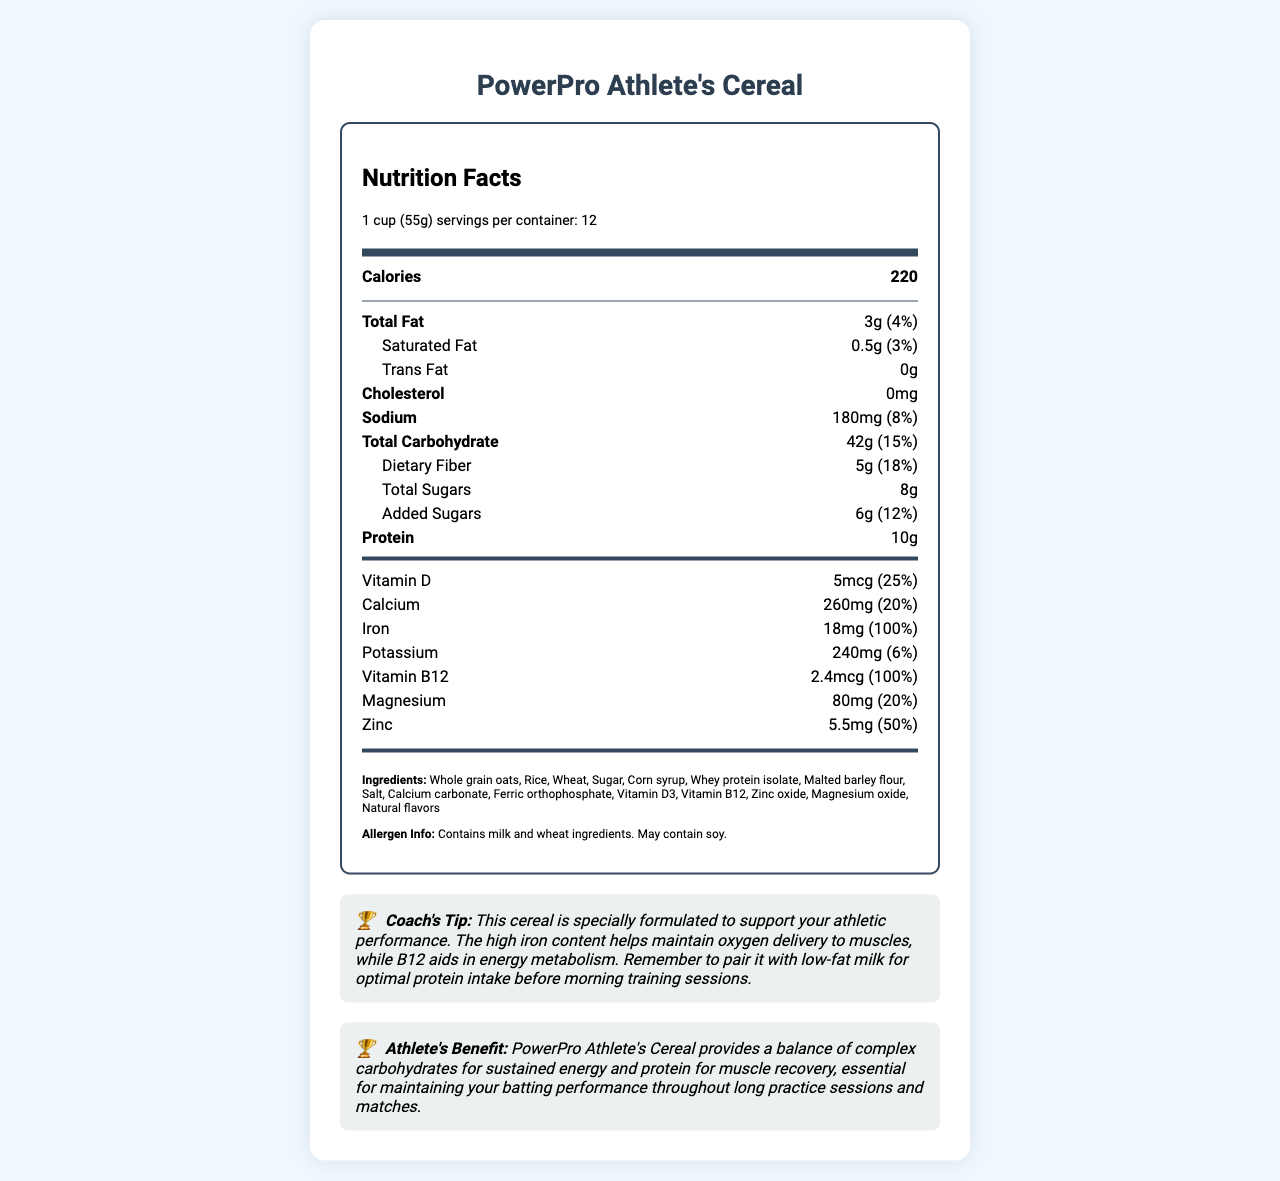what is the serving size? The serving size is indicated at the top of the nutrition facts label as "1 cup (55g)".
Answer: 1 cup (55g) how many servings are there per container? The number of servings per container is listed as 12 on the label.
Answer: 12 how many grams of protein does one serving of PowerPro Athlete's Cereal contain? The amount of protein per serving is listed as 10g on the nutrition label.
Answer: 10g what percentage of the daily value of iron does one serving of this cereal provide? The nutrition label lists iron as providing a daily value of 100% per serving.
Answer: 100% is this cereal gluten-free? The ingredient list contains wheat, indicating that the cereal is not gluten-free.
Answer: No how much sodium is in one serving of the cereal? The sodium content per serving is listed as 180mg on the nutrition label.
Answer: 180mg what is the main benefit of iron mentioned in the coach's tip? The coach's tip specifically mentions that the high iron content helps maintain oxygen delivery to muscles.
Answer: Helps maintain oxygen delivery to muscles what are the allergens present in this cereal? The allergen information indicates the cereal contains milk and wheat ingredients and may contain soy.
Answer: Milk and wheat; may contain soy which vitamin contributes to 25% of the daily value in this cereal? The daily value contribution of Vitamin D is noted as 25% on the nutrition label.
Answer: Vitamin D what macronutrient-related advice does the coach give for consuming this cereal? The coach's tip advises pairing the cereal with low-fat milk for optimal protein intake before morning training sessions.
Answer: Pair it with low-fat milk for optimal protein intake before morning training sessions how many grams of total carbohydrates are in one serving? The total carbohydrate content per serving is listed as 42g on the nutrition label.
Answer: 42g what is the primary benefit of consuming this cereal for athletes? The athlete's benefit section highlights that the cereal provides complex carbohydrates for sustained energy and protein for muscle recovery, essential for maintaining performance.
Answer: Provides complex carbohydrates for sustained energy and protein for muscle recovery what is the total fat content and its percentage of daily value? The total fat content is listed as 3g and the daily value percentage is 4% on the nutrition label.
Answer: 3g (4%) which one of the following is NOT an ingredient in PowerPro Athlete's Cereal? A. Whole grain oats B. Rice C. Malted barley flour D. Almonds Almonds are not listed in the ingredients; the other options are all ingredients in the cereal.
Answer: D. Almonds how much dietary fiber does one serving provide? A. 2g B. 5g C. 10g D. 8g The dietary fiber content is listed as 5g per serving on the nutrition label.
Answer: B. 5g does this cereal contain trans fat? The nutrition label indicates 0g of trans fat per serving.
Answer: No can you determine the cost of one container of PowerPro Athlete's Cereal from this document? The document does not provide any pricing information, so the cost cannot be determined.
Answer: Not enough information summarize the document. The document provides detailed nutritional information about PowerPro Athlete's Cereal, highlighting its benefits for athletes. The nutrition label, ingredients list, allergen information, and coach's tip are clearly presented to emphasize the cereal’s role in supporting athletic performance.
Answer: PowerPro Athlete's Cereal is a vitamin-fortified breakfast cereal designed for athletes. Each 1 cup (55g) serving provides 220 calories, 3g of total fat (4% DV), 42g of carbohydrates (15% DV), 10g of protein, and various vitamins and minerals tailored to support athletic performance, such as iron (100% DV) and vitamin B12 (100% DV). The cereal includes whole grain oats, rice, wheat, sugar, whey protein isolate, and other ingredients, and contains milk and wheat, with a potential for soy. It's recommended by a coach to pair with low-fat milk for optimal protein intake before training. The main athletic benefits highlighted are sustained energy from complex carbohydrates and muscle recovery from protein. 